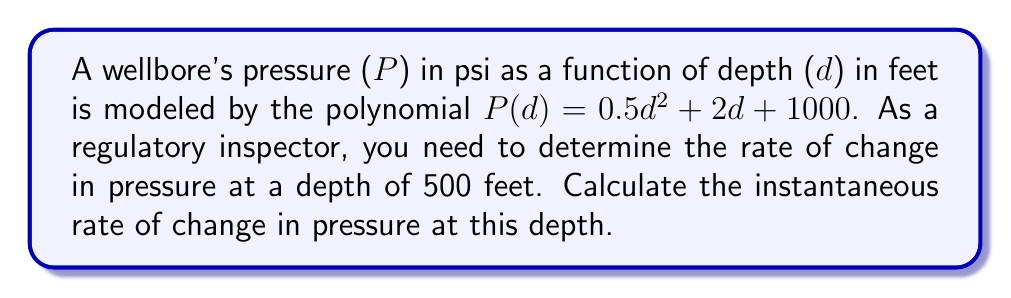Give your solution to this math problem. To find the instantaneous rate of change in pressure at a specific depth, we need to calculate the derivative of the pressure function $P(d)$ and then evaluate it at the given depth.

1. Given pressure function: $P(d) = 0.5d^2 + 2d + 1000$

2. Calculate the derivative $P'(d)$:
   $P'(d) = \frac{d}{dd}(0.5d^2 + 2d + 1000)$
   $P'(d) = 0.5 \cdot 2d + 2 + 0$
   $P'(d) = d + 2$

3. The derivative $P'(d)$ represents the instantaneous rate of change in pressure with respect to depth.

4. Evaluate $P'(d)$ at d = 500 feet:
   $P'(500) = 500 + 2 = 502$

Therefore, the instantaneous rate of change in pressure at a depth of 500 feet is 502 psi/ft.
Answer: 502 psi/ft 